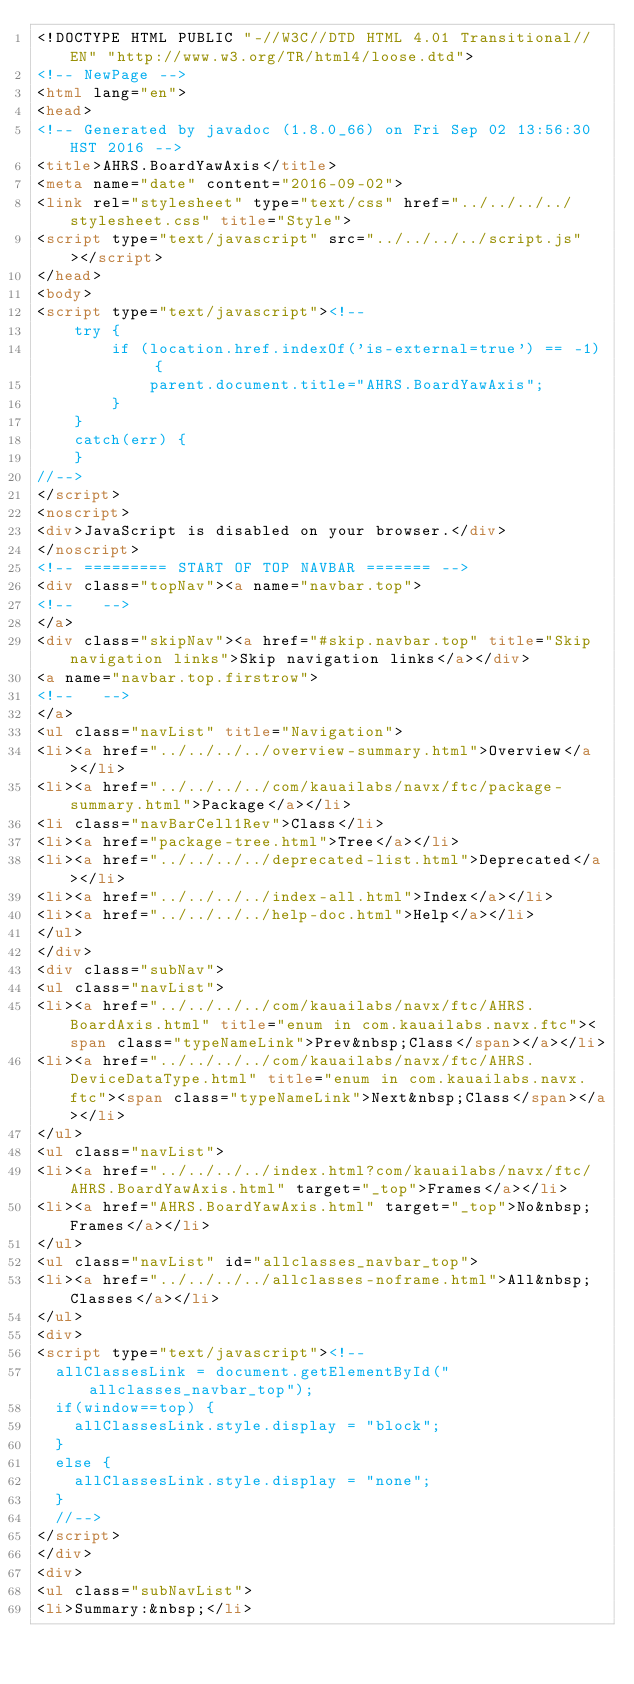Convert code to text. <code><loc_0><loc_0><loc_500><loc_500><_HTML_><!DOCTYPE HTML PUBLIC "-//W3C//DTD HTML 4.01 Transitional//EN" "http://www.w3.org/TR/html4/loose.dtd">
<!-- NewPage -->
<html lang="en">
<head>
<!-- Generated by javadoc (1.8.0_66) on Fri Sep 02 13:56:30 HST 2016 -->
<title>AHRS.BoardYawAxis</title>
<meta name="date" content="2016-09-02">
<link rel="stylesheet" type="text/css" href="../../../../stylesheet.css" title="Style">
<script type="text/javascript" src="../../../../script.js"></script>
</head>
<body>
<script type="text/javascript"><!--
    try {
        if (location.href.indexOf('is-external=true') == -1) {
            parent.document.title="AHRS.BoardYawAxis";
        }
    }
    catch(err) {
    }
//-->
</script>
<noscript>
<div>JavaScript is disabled on your browser.</div>
</noscript>
<!-- ========= START OF TOP NAVBAR ======= -->
<div class="topNav"><a name="navbar.top">
<!--   -->
</a>
<div class="skipNav"><a href="#skip.navbar.top" title="Skip navigation links">Skip navigation links</a></div>
<a name="navbar.top.firstrow">
<!--   -->
</a>
<ul class="navList" title="Navigation">
<li><a href="../../../../overview-summary.html">Overview</a></li>
<li><a href="../../../../com/kauailabs/navx/ftc/package-summary.html">Package</a></li>
<li class="navBarCell1Rev">Class</li>
<li><a href="package-tree.html">Tree</a></li>
<li><a href="../../../../deprecated-list.html">Deprecated</a></li>
<li><a href="../../../../index-all.html">Index</a></li>
<li><a href="../../../../help-doc.html">Help</a></li>
</ul>
</div>
<div class="subNav">
<ul class="navList">
<li><a href="../../../../com/kauailabs/navx/ftc/AHRS.BoardAxis.html" title="enum in com.kauailabs.navx.ftc"><span class="typeNameLink">Prev&nbsp;Class</span></a></li>
<li><a href="../../../../com/kauailabs/navx/ftc/AHRS.DeviceDataType.html" title="enum in com.kauailabs.navx.ftc"><span class="typeNameLink">Next&nbsp;Class</span></a></li>
</ul>
<ul class="navList">
<li><a href="../../../../index.html?com/kauailabs/navx/ftc/AHRS.BoardYawAxis.html" target="_top">Frames</a></li>
<li><a href="AHRS.BoardYawAxis.html" target="_top">No&nbsp;Frames</a></li>
</ul>
<ul class="navList" id="allclasses_navbar_top">
<li><a href="../../../../allclasses-noframe.html">All&nbsp;Classes</a></li>
</ul>
<div>
<script type="text/javascript"><!--
  allClassesLink = document.getElementById("allclasses_navbar_top");
  if(window==top) {
    allClassesLink.style.display = "block";
  }
  else {
    allClassesLink.style.display = "none";
  }
  //-->
</script>
</div>
<div>
<ul class="subNavList">
<li>Summary:&nbsp;</li></code> 